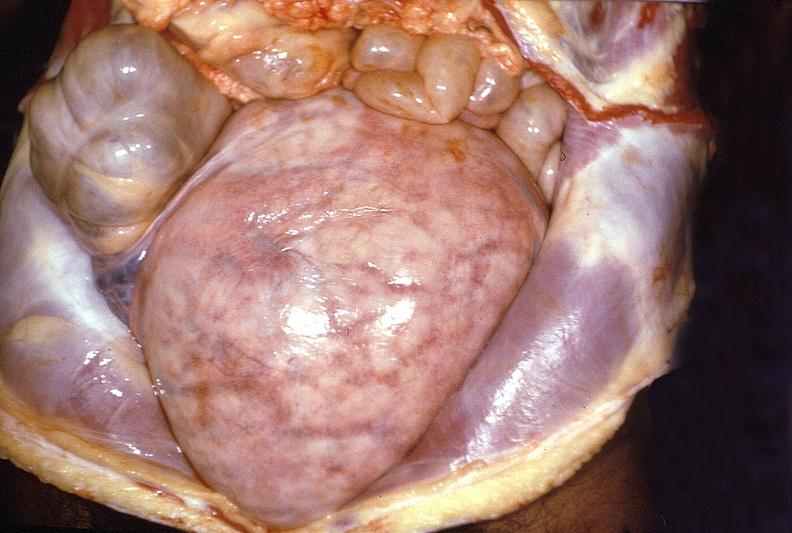what does this image show?
Answer the question using a single word or phrase. Gravid uterus 